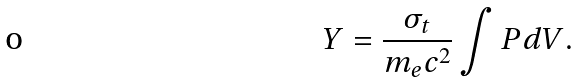Convert formula to latex. <formula><loc_0><loc_0><loc_500><loc_500>Y = \frac { \sigma _ { t } } { m _ { e } c ^ { 2 } } \int { P d V } .</formula> 